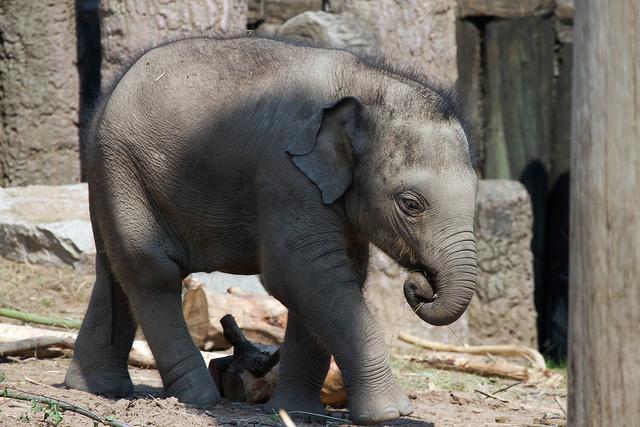How many eyes are there?
Short answer required. 1. Is the rocks the same color as an elephant?
Write a very short answer. Yes. What animal is this?
Quick response, please. Elephant. Is this an adult elephant?
Give a very brief answer. No. How old is the elephant?
Quick response, please. Young. 